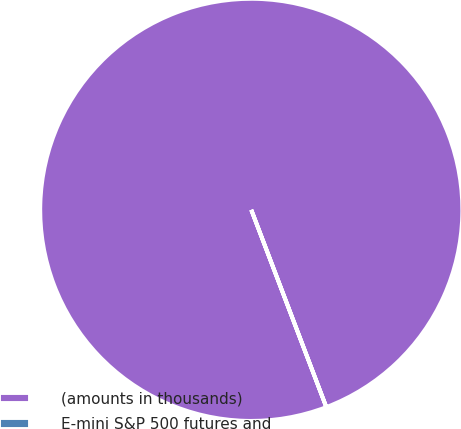Convert chart to OTSL. <chart><loc_0><loc_0><loc_500><loc_500><pie_chart><fcel>(amounts in thousands)<fcel>E-mini S&P 500 futures and<nl><fcel>100.0%<fcel>0.0%<nl></chart> 